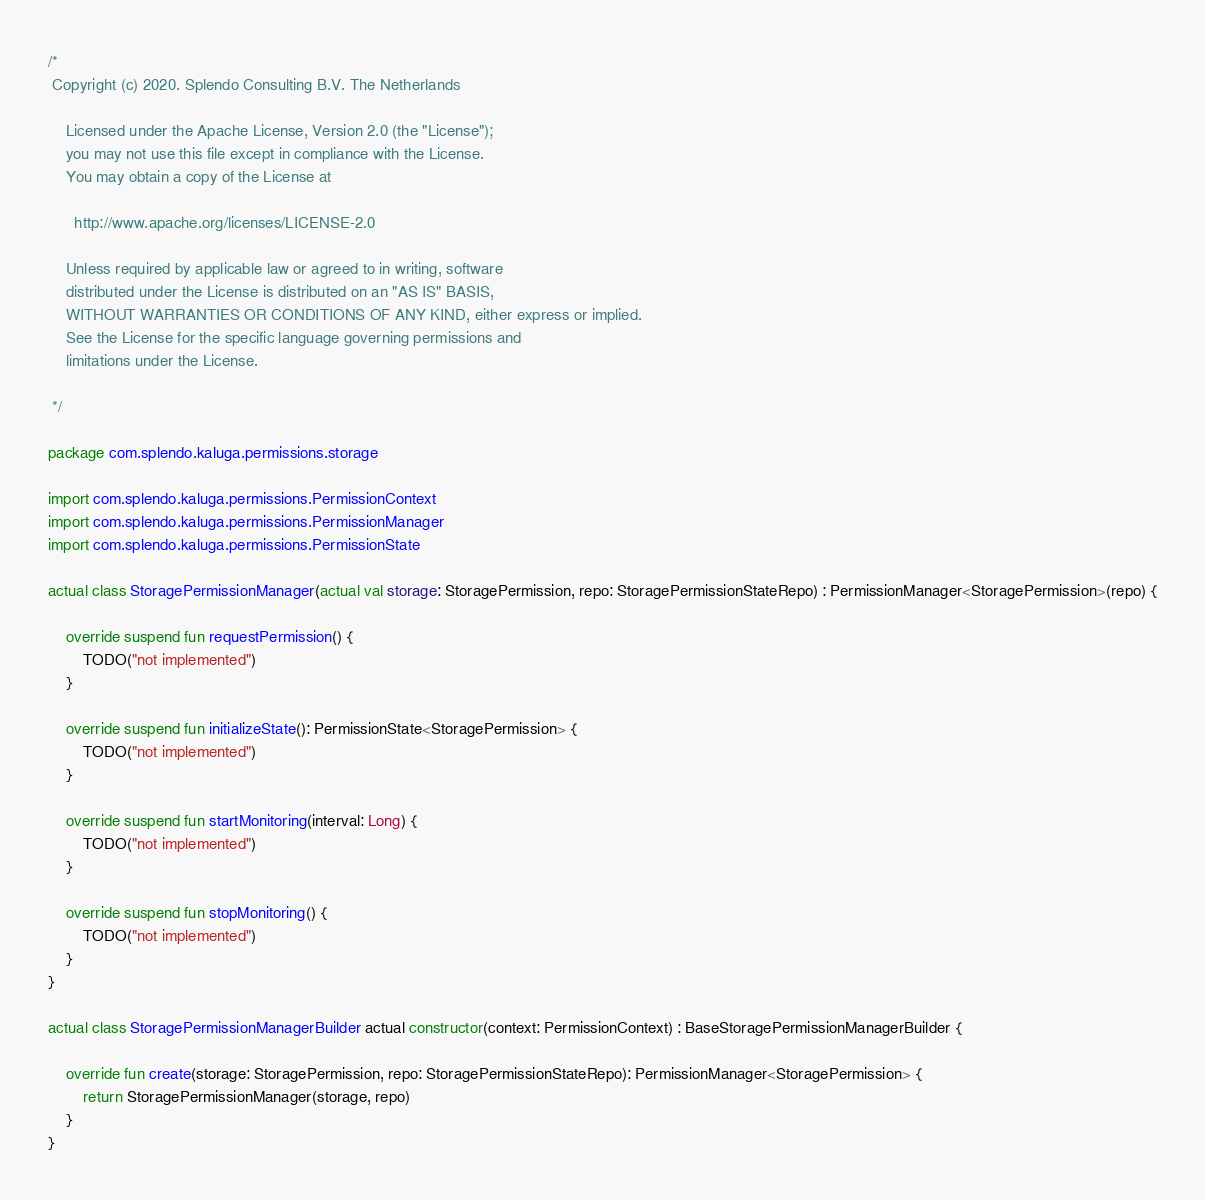Convert code to text. <code><loc_0><loc_0><loc_500><loc_500><_Kotlin_>/*
 Copyright (c) 2020. Splendo Consulting B.V. The Netherlands

    Licensed under the Apache License, Version 2.0 (the "License");
    you may not use this file except in compliance with the License.
    You may obtain a copy of the License at

      http://www.apache.org/licenses/LICENSE-2.0

    Unless required by applicable law or agreed to in writing, software
    distributed under the License is distributed on an "AS IS" BASIS,
    WITHOUT WARRANTIES OR CONDITIONS OF ANY KIND, either express or implied.
    See the License for the specific language governing permissions and
    limitations under the License.

 */

package com.splendo.kaluga.permissions.storage

import com.splendo.kaluga.permissions.PermissionContext
import com.splendo.kaluga.permissions.PermissionManager
import com.splendo.kaluga.permissions.PermissionState

actual class StoragePermissionManager(actual val storage: StoragePermission, repo: StoragePermissionStateRepo) : PermissionManager<StoragePermission>(repo) {

    override suspend fun requestPermission() {
        TODO("not implemented")
    }

    override suspend fun initializeState(): PermissionState<StoragePermission> {
        TODO("not implemented")
    }

    override suspend fun startMonitoring(interval: Long) {
        TODO("not implemented")
    }

    override suspend fun stopMonitoring() {
        TODO("not implemented")
    }
}

actual class StoragePermissionManagerBuilder actual constructor(context: PermissionContext) : BaseStoragePermissionManagerBuilder {

    override fun create(storage: StoragePermission, repo: StoragePermissionStateRepo): PermissionManager<StoragePermission> {
        return StoragePermissionManager(storage, repo)
    }
}
</code> 